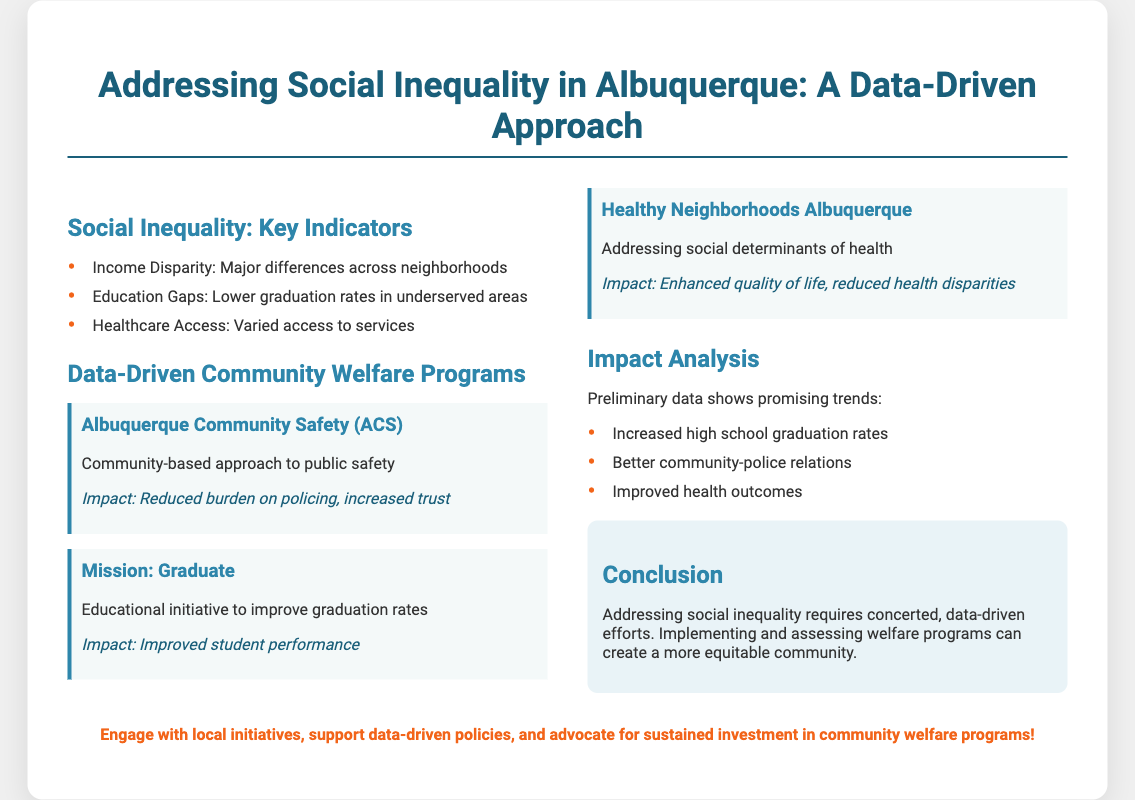What are the key indicators of social inequality? The key indicators listed in the document include income disparity, education gaps, and healthcare access.
Answer: Income Disparity, Education Gaps, Healthcare Access What is the primary goal of the Albuquerque Community Safety program? The program focuses on a community-based approach to public safety, aimed at reducing the burden on policing.
Answer: Community-based approach to public safety What was the impact of the Mission: Graduate program? The document states that the program resulted in improved student performance.
Answer: Improved student performance Which program addresses social determinants of health? The program specifically mentioned for addressing social determinants of health is Healthy Neighborhoods Albuquerque.
Answer: Healthy Neighborhoods Albuquerque What promising trends were identified in the impact analysis? The document highlights increased high school graduation rates, better community-police relations, and improved health outcomes.
Answer: Increased high school graduation rates, better community-police relations, improved health outcomes What type of approach is emphasized for addressing social inequality? The document emphasizes a concerted, data-driven approach to tackle social inequality.
Answer: Data-driven approach What can residents of Albuquerque do to support community welfare programs? The call-to-action suggests engaging with local initiatives and advocating for sustained investment in community welfare programs.
Answer: Engage with local initiatives, support data-driven policies What does the conclusion suggest is necessary for creating a more equitable community? The conclusion states that implementing and assessing welfare programs is required for a more equitable community.
Answer: Implementing and assessing welfare programs 